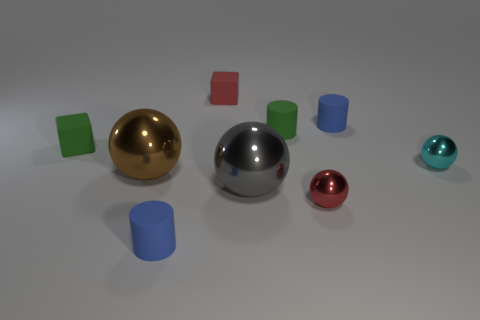Subtract all cyan spheres. How many spheres are left? 3 Subtract all blue rubber cylinders. How many cylinders are left? 1 Add 1 green matte cylinders. How many objects exist? 10 Subtract all yellow balls. Subtract all yellow cylinders. How many balls are left? 4 Add 1 matte cylinders. How many matte cylinders are left? 4 Add 6 small metallic objects. How many small metallic objects exist? 8 Subtract 0 cyan cylinders. How many objects are left? 9 Subtract all cylinders. How many objects are left? 6 Subtract all tiny blue cylinders. Subtract all large brown objects. How many objects are left? 6 